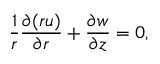<formula> <loc_0><loc_0><loc_500><loc_500>\frac { 1 } { r } \frac { \partial ( r u ) } { \partial r } + \frac { \partial w } { \partial z } = 0 ,</formula> 